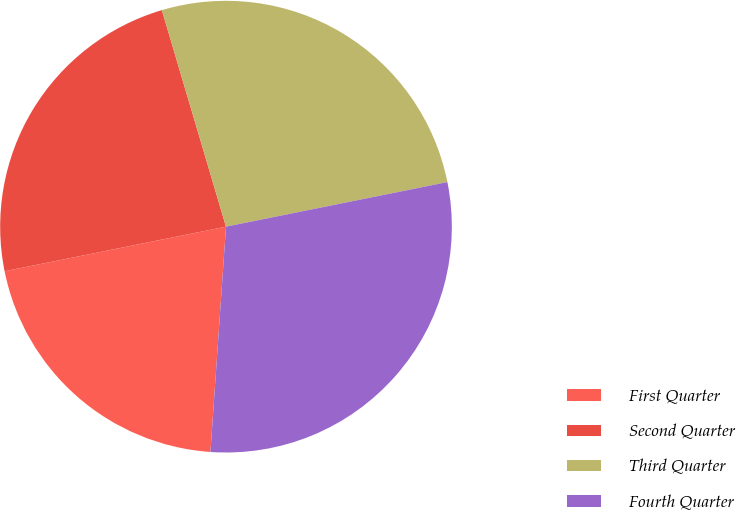Convert chart to OTSL. <chart><loc_0><loc_0><loc_500><loc_500><pie_chart><fcel>First Quarter<fcel>Second Quarter<fcel>Third Quarter<fcel>Fourth Quarter<nl><fcel>20.74%<fcel>23.58%<fcel>26.42%<fcel>29.26%<nl></chart> 